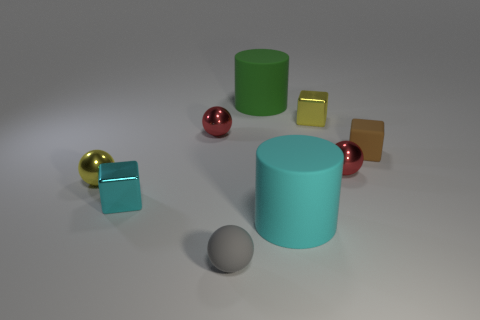What number of objects are either blue matte things or metal blocks that are behind the small brown object?
Your answer should be very brief. 1. What number of other objects are the same shape as the tiny gray matte object?
Your answer should be very brief. 3. Is the number of yellow metal blocks that are behind the small yellow cube less than the number of green rubber objects in front of the gray object?
Your response must be concise. No. Is there any other thing that has the same material as the small gray sphere?
Your answer should be compact. Yes. The small cyan thing that is the same material as the yellow cube is what shape?
Offer a very short reply. Cube. Is there anything else of the same color as the rubber cube?
Provide a short and direct response. No. There is a sphere that is behind the tiny red ball that is on the right side of the large cyan cylinder; what is its color?
Provide a short and direct response. Red. There is a big cylinder that is on the right side of the large thing that is behind the tiny metal cube that is right of the tiny cyan metallic block; what is its material?
Give a very brief answer. Rubber. How many green metal balls are the same size as the yellow shiny sphere?
Your answer should be very brief. 0. What is the material of the object that is both in front of the small cyan object and behind the gray rubber ball?
Your response must be concise. Rubber. 